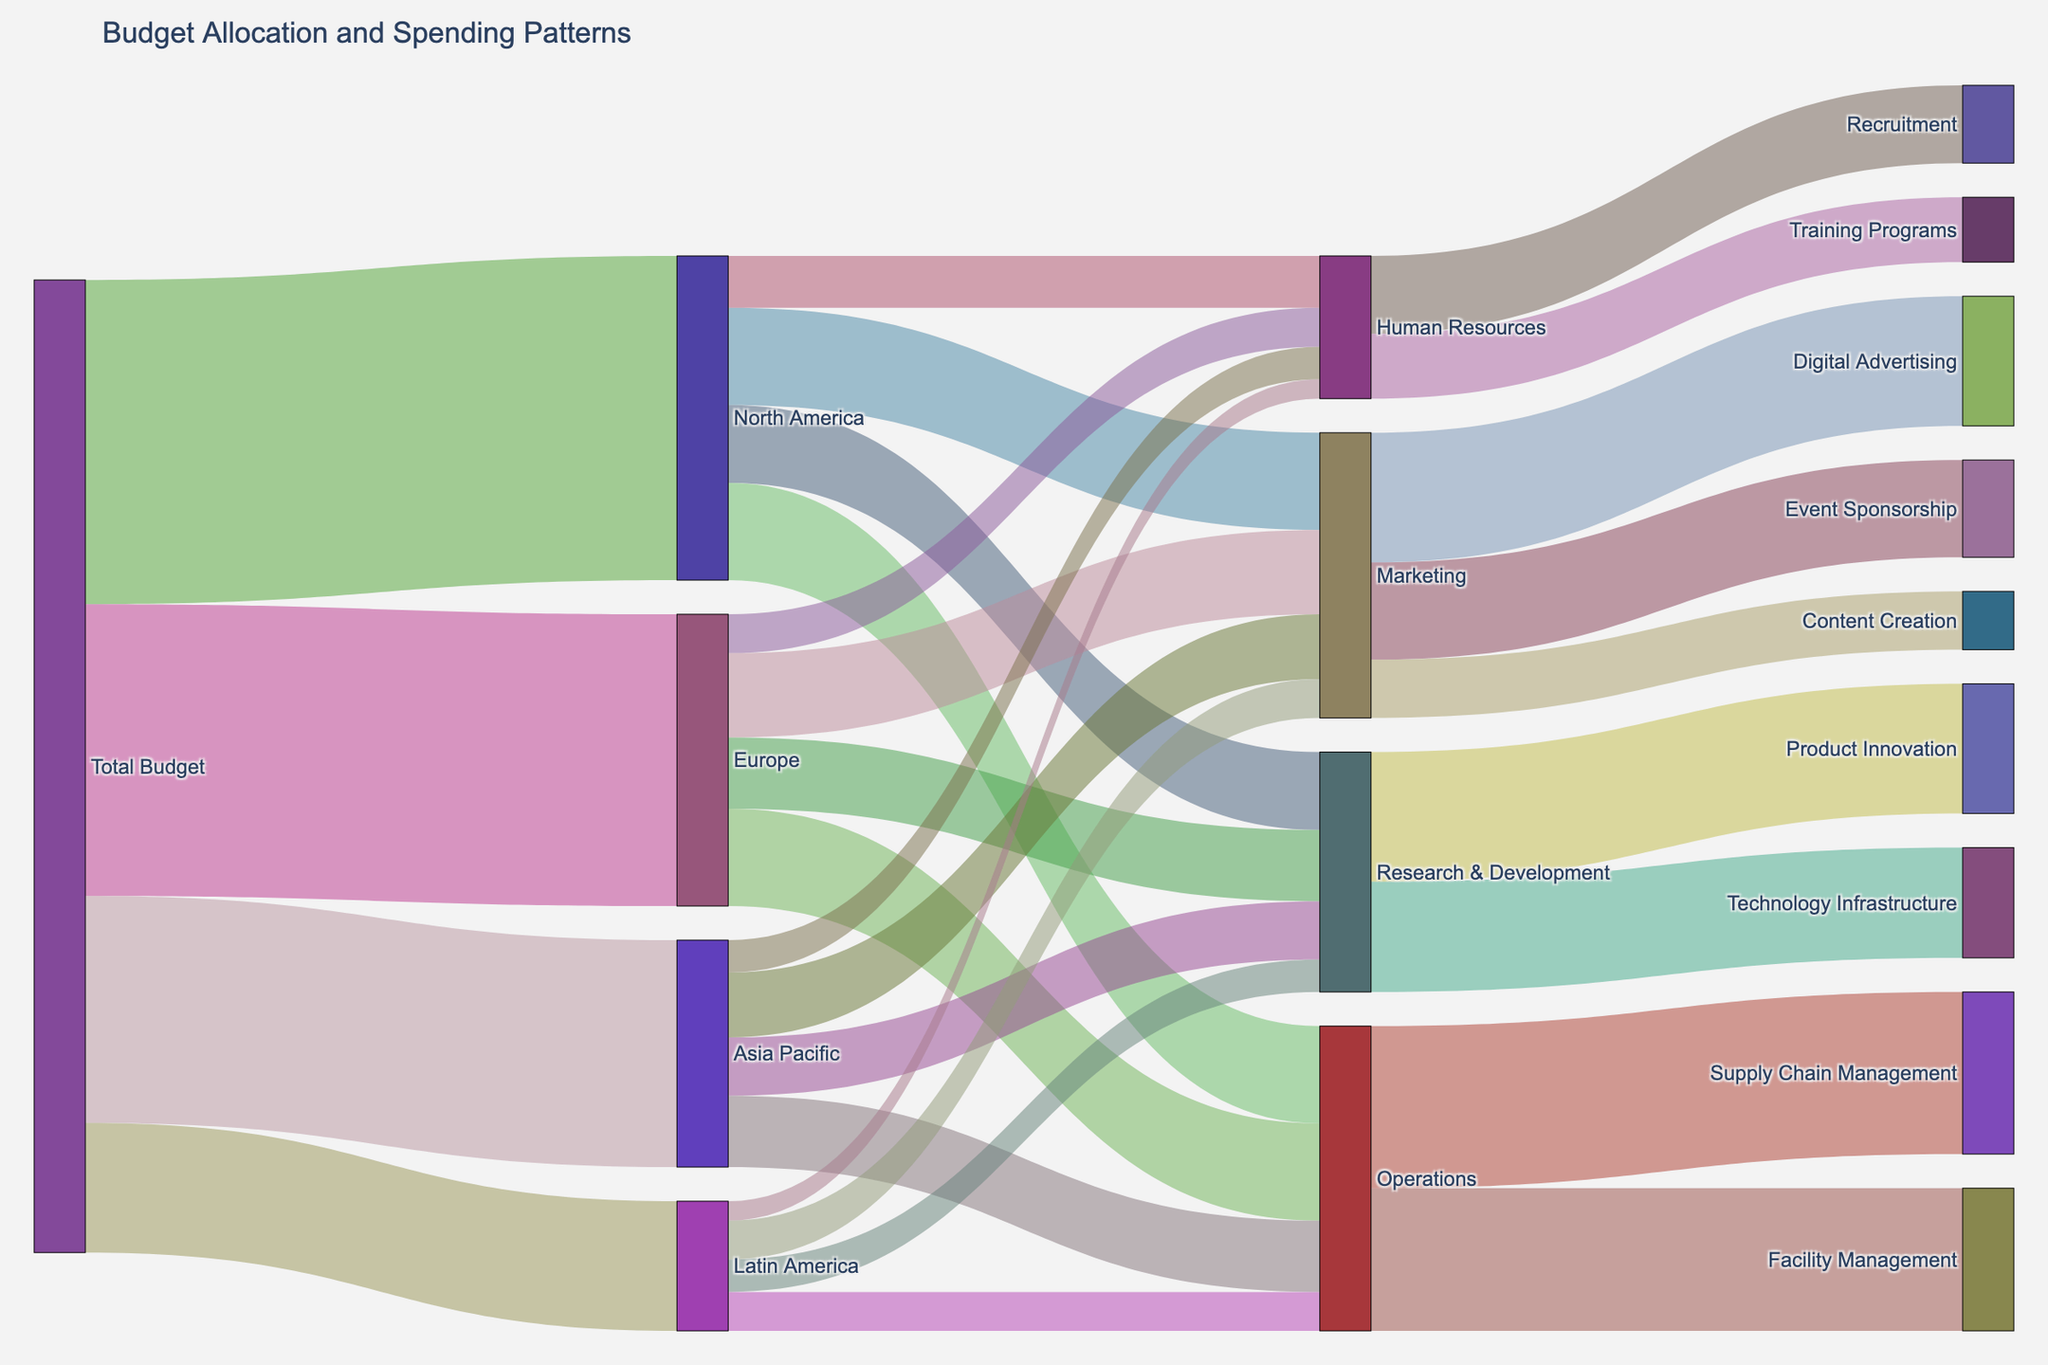What is the width of the link between North America and Marketing? The width of a link in a Sankey diagram represents the value it carries. According to the data, the value for the link between North America and Marketing is 1,500,000.
Answer: 1,500,000 Which region receives the largest portion of the Total Budget? By examining the Sankey diagram, you can compare the widths of the links from the Total Budget to each region. North America has the widest link with a budget allocation of 5,000,000, which is the largest among all regions.
Answer: North America What is the total budget allocation for the Research & Development across all regions? By summing up the values for Research & Development from each region: 1,200,000 (North America) + 1,100,000 (Europe) + 900,000 (Asia Pacific) + 500,000 (Latin America) = 3,700,000.
Answer: 3,700,000 Which department has the highest spending within the Operations category? By comparing the widths of links within Operations, we see that Supply Chain Management has a value of 2,500,000, which is higher than Facility Management (2,200,000).
Answer: Supply Chain Management If the company decides to equally redistribute the budget for Marketing among its categories, what would be the amount allocated to each category? The total budget for Marketing is 2,000,000 (Digital Advertising) + 1,500,000 (Event Sponsorship) + 900,000 (Content Creation) = 4,400,000. Dividing this equally among three categories: 4,400,000 / 3 = 1,466,666.67.
Answer: 1,466,666.67 Which region allocates the least amount to Human Resources? By comparing the widths of the links from each region to Human Resources, Latin America allocates the least amount with a value of 300,000.
Answer: Latin America How much more budget does Europe allocate to Operations compared to Human Resources? First, find the difference: 1,500,000 (Operations) - 600,000 (Human Resources) = 900,000.
Answer: 900,000 Compare the total spending on Marketing between North America and Europe. Which region spends more and by how much? North America spends 1,500,000 on Marketing, and Europe spends 1,300,000. The difference is 1,500,000 - 1,300,000 = 200,000, so North America spends more.
Answer: North America, 200,000 What is the sum of the budgets allocated to Technology Infrastructure and Facility Management? Summing the values: 1,700,000 (Technology Infrastructure) + 2,200,000 (Facility Management) = 3,900,000.
Answer: 3,900,000 How does the spending on Digital Advertising compare to that on Training Programs? Digital Advertising has a budget of 2,000,000 while Training Programs has a budget of 1,000,000. Digital Advertising receives twice as much budget as Training Programs.
Answer: Digital Advertising, twice 